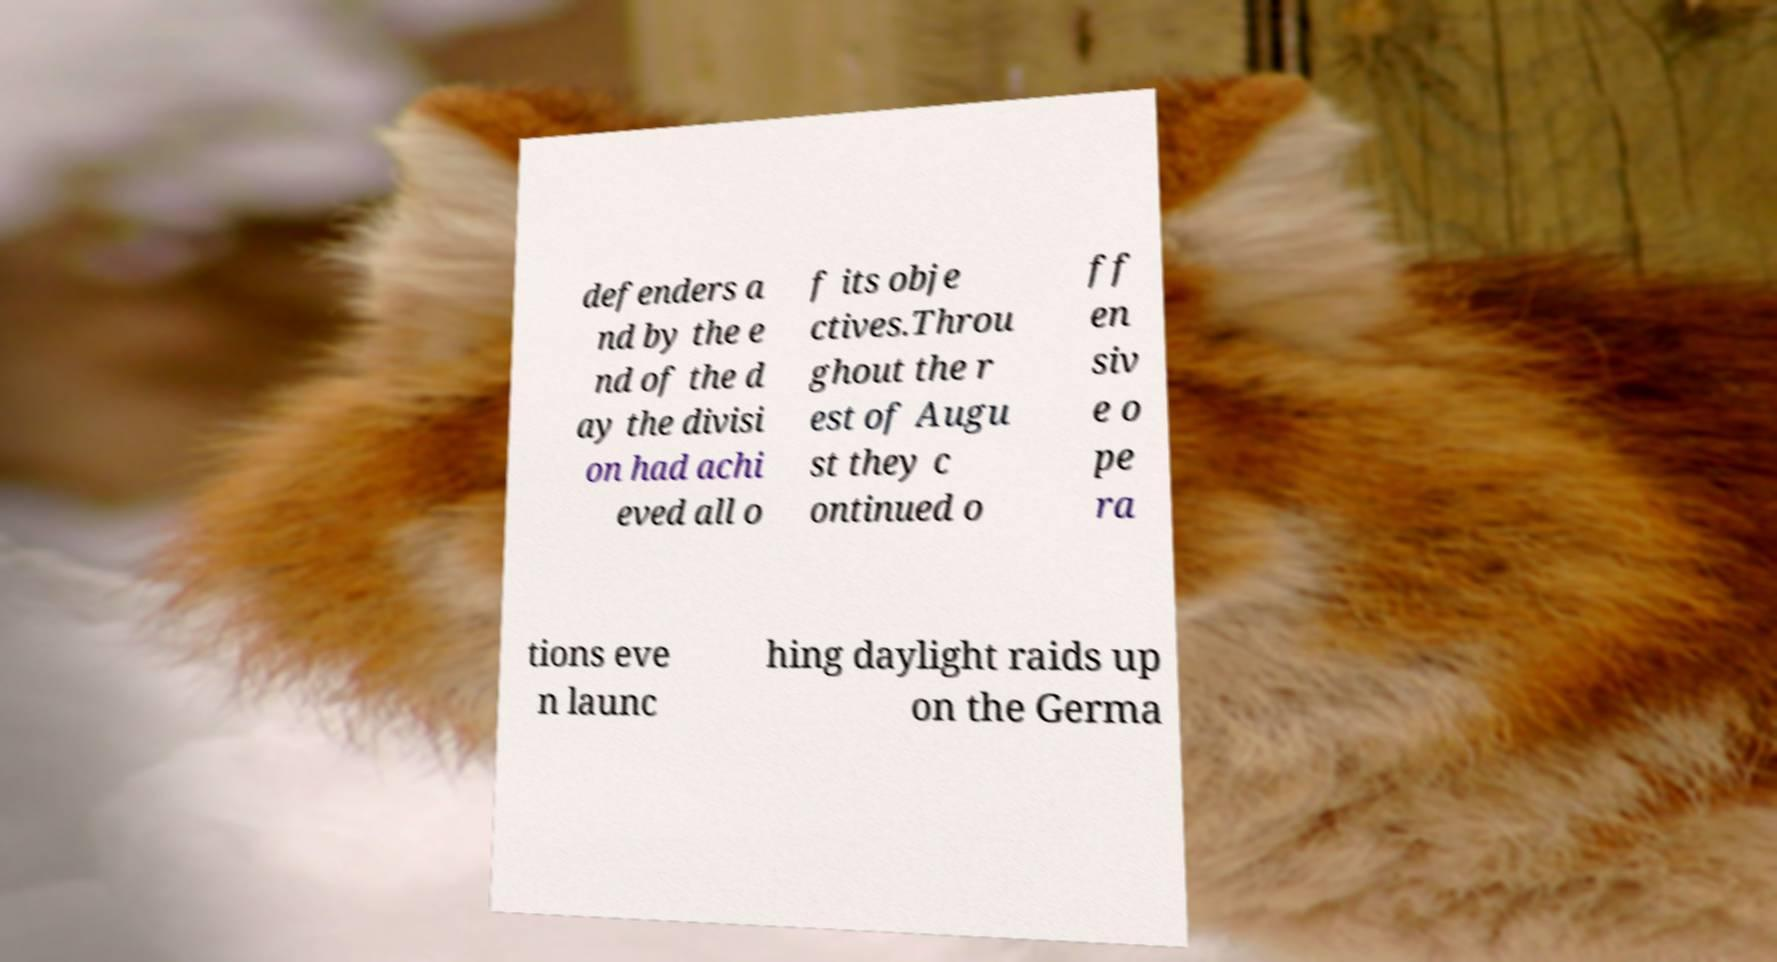Could you extract and type out the text from this image? defenders a nd by the e nd of the d ay the divisi on had achi eved all o f its obje ctives.Throu ghout the r est of Augu st they c ontinued o ff en siv e o pe ra tions eve n launc hing daylight raids up on the Germa 